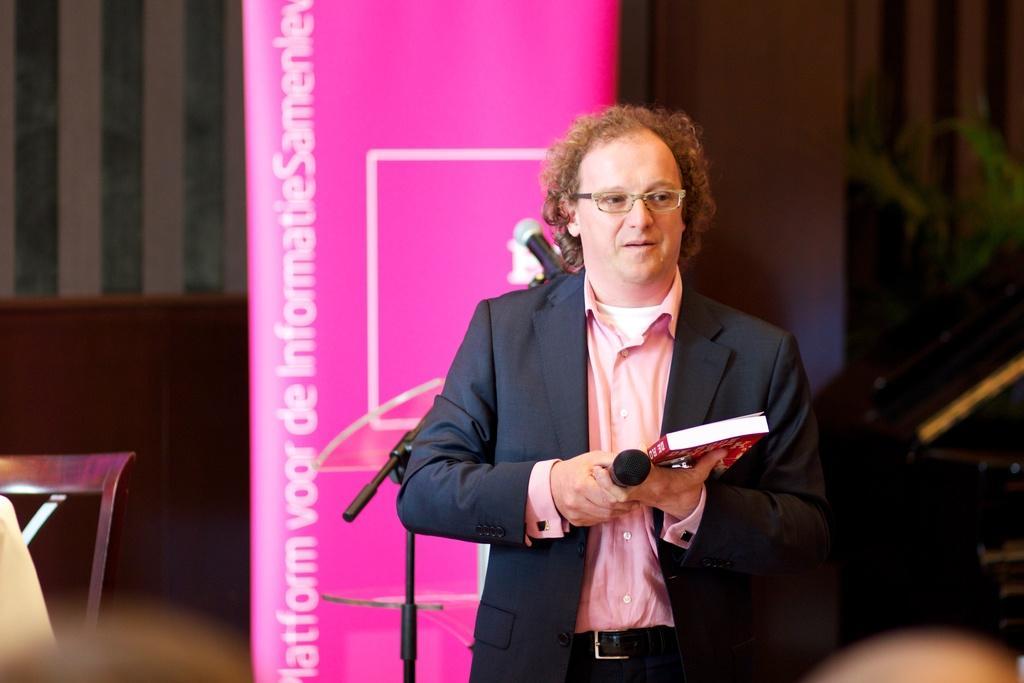Describe this image in one or two sentences. In this image, man in the suit. He hold book and microphone. Behind him, we can see a stand and banner. Left side, there is a wooden chair. And background, we can see a wall. 